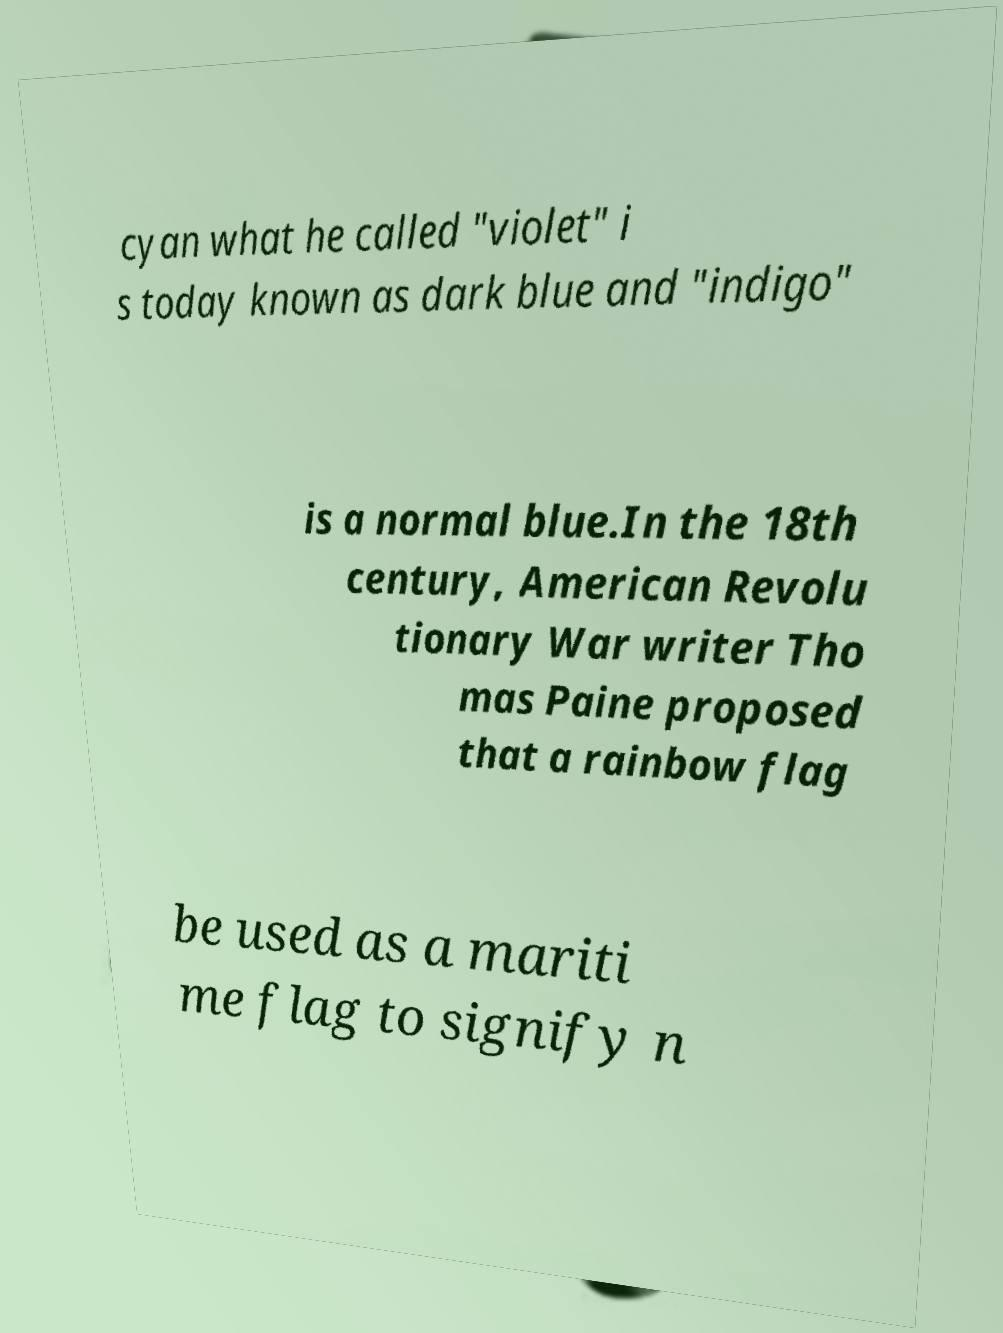I need the written content from this picture converted into text. Can you do that? cyan what he called "violet" i s today known as dark blue and "indigo" is a normal blue.In the 18th century, American Revolu tionary War writer Tho mas Paine proposed that a rainbow flag be used as a mariti me flag to signify n 